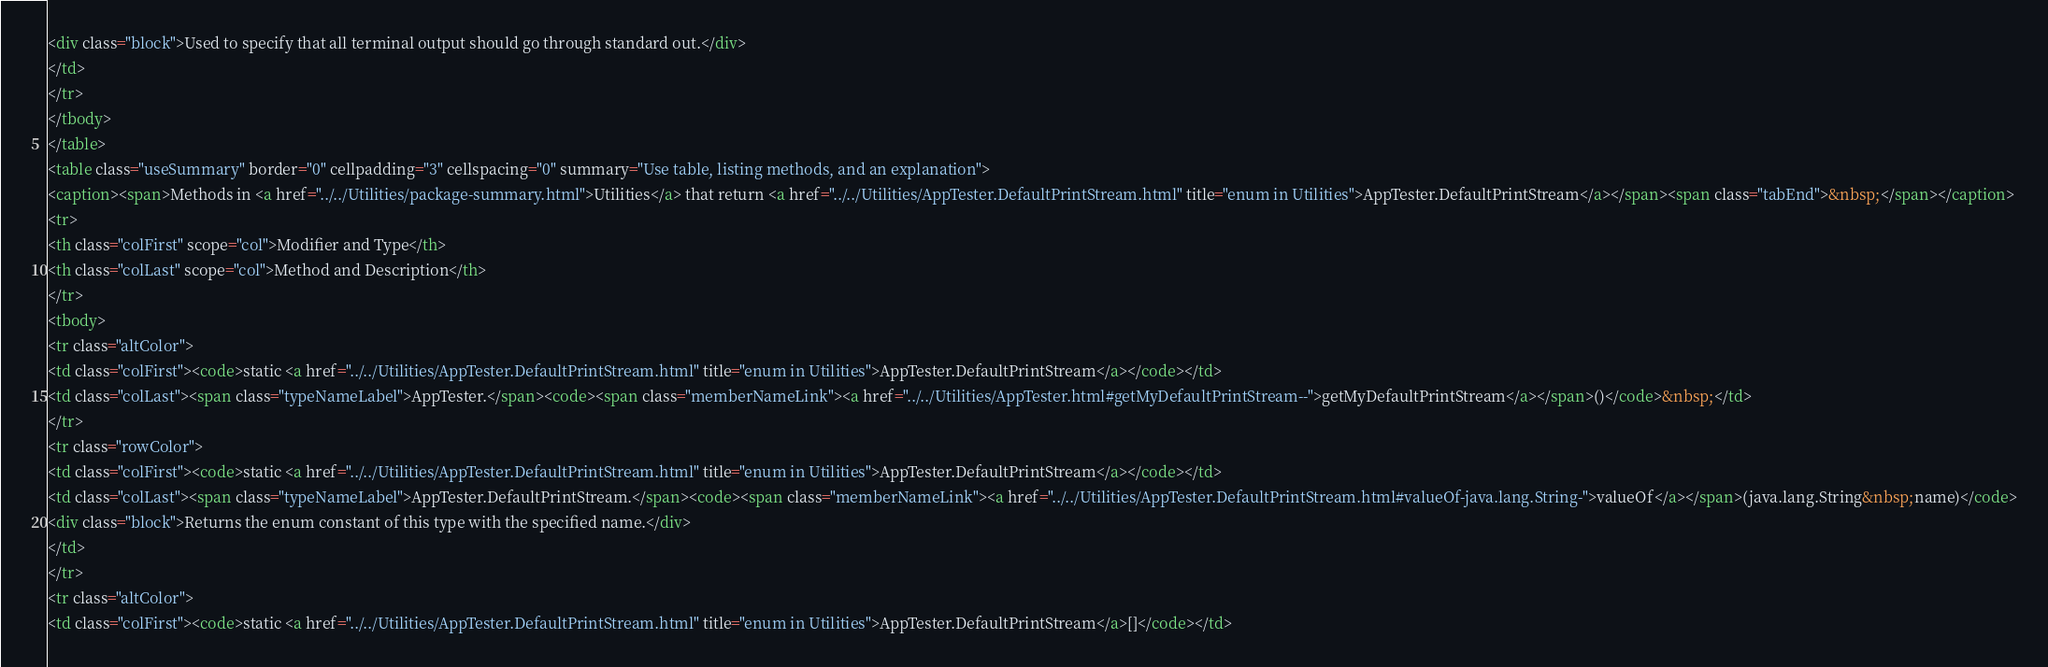Convert code to text. <code><loc_0><loc_0><loc_500><loc_500><_HTML_><div class="block">Used to specify that all terminal output should go through standard out.</div>
</td>
</tr>
</tbody>
</table>
<table class="useSummary" border="0" cellpadding="3" cellspacing="0" summary="Use table, listing methods, and an explanation">
<caption><span>Methods in <a href="../../Utilities/package-summary.html">Utilities</a> that return <a href="../../Utilities/AppTester.DefaultPrintStream.html" title="enum in Utilities">AppTester.DefaultPrintStream</a></span><span class="tabEnd">&nbsp;</span></caption>
<tr>
<th class="colFirst" scope="col">Modifier and Type</th>
<th class="colLast" scope="col">Method and Description</th>
</tr>
<tbody>
<tr class="altColor">
<td class="colFirst"><code>static <a href="../../Utilities/AppTester.DefaultPrintStream.html" title="enum in Utilities">AppTester.DefaultPrintStream</a></code></td>
<td class="colLast"><span class="typeNameLabel">AppTester.</span><code><span class="memberNameLink"><a href="../../Utilities/AppTester.html#getMyDefaultPrintStream--">getMyDefaultPrintStream</a></span>()</code>&nbsp;</td>
</tr>
<tr class="rowColor">
<td class="colFirst"><code>static <a href="../../Utilities/AppTester.DefaultPrintStream.html" title="enum in Utilities">AppTester.DefaultPrintStream</a></code></td>
<td class="colLast"><span class="typeNameLabel">AppTester.DefaultPrintStream.</span><code><span class="memberNameLink"><a href="../../Utilities/AppTester.DefaultPrintStream.html#valueOf-java.lang.String-">valueOf</a></span>(java.lang.String&nbsp;name)</code>
<div class="block">Returns the enum constant of this type with the specified name.</div>
</td>
</tr>
<tr class="altColor">
<td class="colFirst"><code>static <a href="../../Utilities/AppTester.DefaultPrintStream.html" title="enum in Utilities">AppTester.DefaultPrintStream</a>[]</code></td></code> 